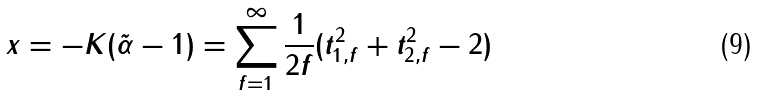<formula> <loc_0><loc_0><loc_500><loc_500>x = - K ( \tilde { \alpha } - 1 ) = \sum _ { f = 1 } ^ { \infty } \frac { 1 } { 2 f } ( t _ { 1 , f } ^ { 2 } + t _ { 2 , f } ^ { 2 } - 2 )</formula> 